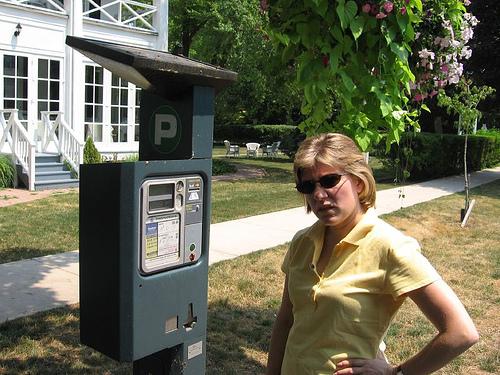How is the parking pay station powered?
Write a very short answer. Solar. What is she standing next to?
Quick response, please. Parking meter. What color is the girl's shirt?
Give a very brief answer. Yellow. 